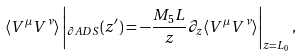<formula> <loc_0><loc_0><loc_500><loc_500>\langle V ^ { \mu } V ^ { \nu } \rangle \left | _ { \partial A D S } ( z ^ { \prime } ) = - \frac { M _ { 5 } L } { z } \partial _ { z } \langle V ^ { \mu } V ^ { \nu } \rangle \right | _ { z = L _ { 0 } } ,</formula> 